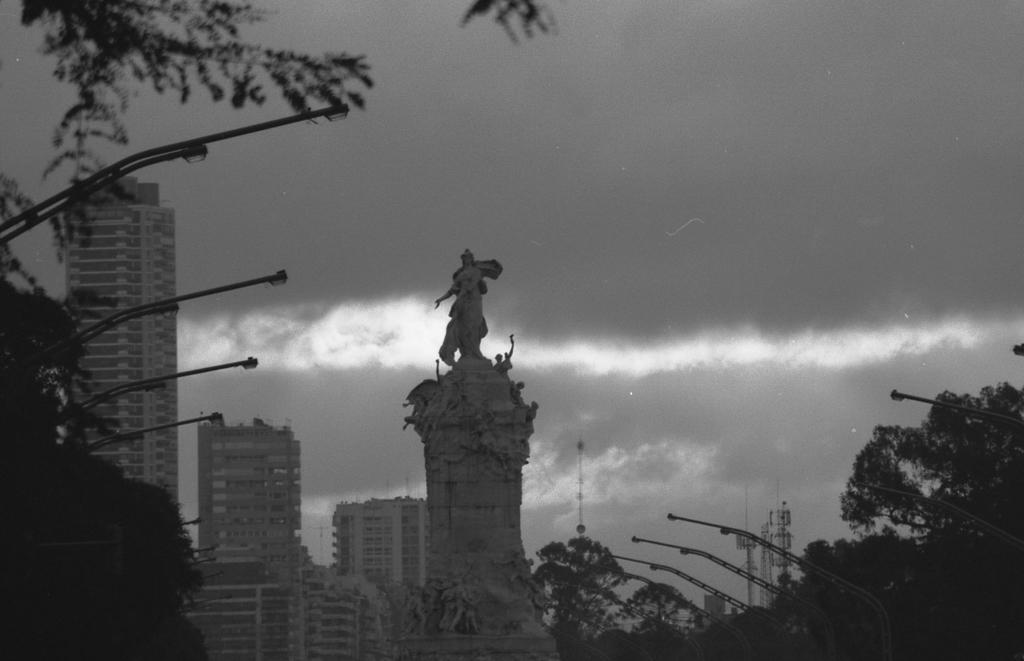Could you give a brief overview of what you see in this image? In the center of the image there is a statue. In the background we can see buildings, street lights, trees, towers, sky and clouds. 